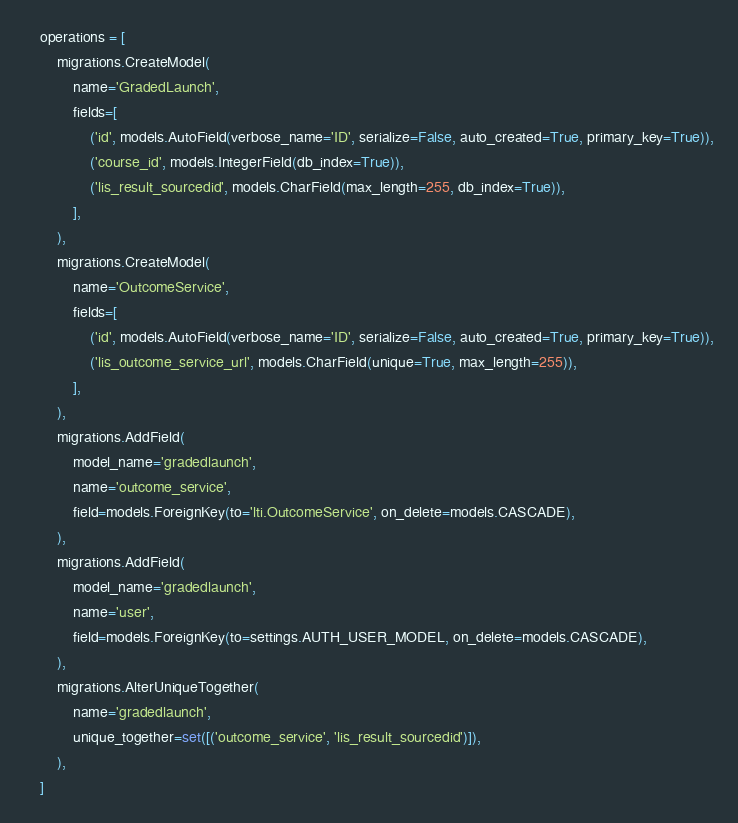<code> <loc_0><loc_0><loc_500><loc_500><_Python_>    operations = [
        migrations.CreateModel(
            name='GradedLaunch',
            fields=[
                ('id', models.AutoField(verbose_name='ID', serialize=False, auto_created=True, primary_key=True)),
                ('course_id', models.IntegerField(db_index=True)),
                ('lis_result_sourcedid', models.CharField(max_length=255, db_index=True)),
            ],
        ),
        migrations.CreateModel(
            name='OutcomeService',
            fields=[
                ('id', models.AutoField(verbose_name='ID', serialize=False, auto_created=True, primary_key=True)),
                ('lis_outcome_service_url', models.CharField(unique=True, max_length=255)),
            ],
        ),
        migrations.AddField(
            model_name='gradedlaunch',
            name='outcome_service',
            field=models.ForeignKey(to='lti.OutcomeService', on_delete=models.CASCADE),
        ),
        migrations.AddField(
            model_name='gradedlaunch',
            name='user',
            field=models.ForeignKey(to=settings.AUTH_USER_MODEL, on_delete=models.CASCADE),
        ),
        migrations.AlterUniqueTogether(
            name='gradedlaunch',
            unique_together=set([('outcome_service', 'lis_result_sourcedid')]),
        ),
    ]
</code> 